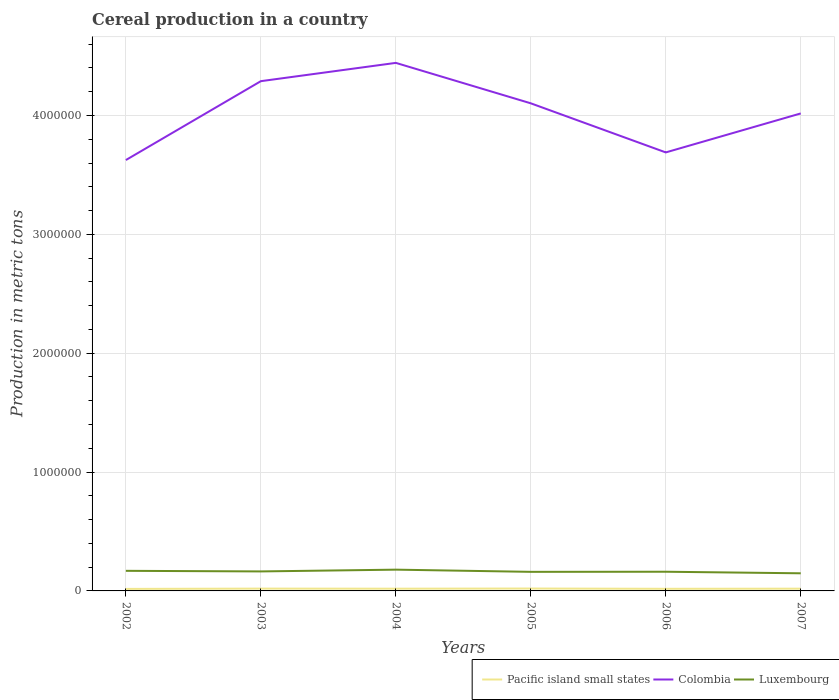Does the line corresponding to Pacific island small states intersect with the line corresponding to Luxembourg?
Offer a very short reply. No. Across all years, what is the maximum total cereal production in Colombia?
Ensure brevity in your answer.  3.63e+06. In which year was the total cereal production in Colombia maximum?
Provide a short and direct response. 2002. What is the total total cereal production in Pacific island small states in the graph?
Provide a short and direct response. -969. What is the difference between the highest and the second highest total cereal production in Pacific island small states?
Keep it short and to the point. 3224. What is the difference between the highest and the lowest total cereal production in Pacific island small states?
Offer a very short reply. 4. How many years are there in the graph?
Offer a very short reply. 6. Does the graph contain any zero values?
Your answer should be compact. No. How many legend labels are there?
Keep it short and to the point. 3. What is the title of the graph?
Your answer should be very brief. Cereal production in a country. Does "Upper middle income" appear as one of the legend labels in the graph?
Make the answer very short. No. What is the label or title of the X-axis?
Make the answer very short. Years. What is the label or title of the Y-axis?
Keep it short and to the point. Production in metric tons. What is the Production in metric tons of Pacific island small states in 2002?
Offer a very short reply. 1.69e+04. What is the Production in metric tons of Colombia in 2002?
Provide a short and direct response. 3.63e+06. What is the Production in metric tons in Luxembourg in 2002?
Provide a succinct answer. 1.69e+05. What is the Production in metric tons in Pacific island small states in 2003?
Provide a succinct answer. 1.95e+04. What is the Production in metric tons in Colombia in 2003?
Your answer should be compact. 4.29e+06. What is the Production in metric tons in Luxembourg in 2003?
Offer a very short reply. 1.64e+05. What is the Production in metric tons of Pacific island small states in 2004?
Offer a terse response. 1.88e+04. What is the Production in metric tons in Colombia in 2004?
Your answer should be very brief. 4.44e+06. What is the Production in metric tons of Luxembourg in 2004?
Make the answer very short. 1.79e+05. What is the Production in metric tons in Pacific island small states in 2005?
Keep it short and to the point. 2.01e+04. What is the Production in metric tons of Colombia in 2005?
Make the answer very short. 4.10e+06. What is the Production in metric tons of Luxembourg in 2005?
Offer a terse response. 1.61e+05. What is the Production in metric tons in Pacific island small states in 2006?
Make the answer very short. 1.79e+04. What is the Production in metric tons of Colombia in 2006?
Your answer should be compact. 3.69e+06. What is the Production in metric tons of Luxembourg in 2006?
Offer a terse response. 1.61e+05. What is the Production in metric tons in Pacific island small states in 2007?
Make the answer very short. 1.90e+04. What is the Production in metric tons in Colombia in 2007?
Provide a short and direct response. 4.02e+06. What is the Production in metric tons of Luxembourg in 2007?
Provide a short and direct response. 1.48e+05. Across all years, what is the maximum Production in metric tons of Pacific island small states?
Offer a terse response. 2.01e+04. Across all years, what is the maximum Production in metric tons of Colombia?
Keep it short and to the point. 4.44e+06. Across all years, what is the maximum Production in metric tons in Luxembourg?
Make the answer very short. 1.79e+05. Across all years, what is the minimum Production in metric tons in Pacific island small states?
Provide a succinct answer. 1.69e+04. Across all years, what is the minimum Production in metric tons in Colombia?
Provide a succinct answer. 3.63e+06. Across all years, what is the minimum Production in metric tons of Luxembourg?
Your answer should be very brief. 1.48e+05. What is the total Production in metric tons in Pacific island small states in the graph?
Your answer should be very brief. 1.12e+05. What is the total Production in metric tons of Colombia in the graph?
Make the answer very short. 2.42e+07. What is the total Production in metric tons in Luxembourg in the graph?
Provide a succinct answer. 9.83e+05. What is the difference between the Production in metric tons in Pacific island small states in 2002 and that in 2003?
Offer a very short reply. -2565. What is the difference between the Production in metric tons in Colombia in 2002 and that in 2003?
Your answer should be compact. -6.64e+05. What is the difference between the Production in metric tons of Luxembourg in 2002 and that in 2003?
Provide a short and direct response. 4928. What is the difference between the Production in metric tons of Pacific island small states in 2002 and that in 2004?
Make the answer very short. -1947. What is the difference between the Production in metric tons of Colombia in 2002 and that in 2004?
Offer a very short reply. -8.18e+05. What is the difference between the Production in metric tons in Luxembourg in 2002 and that in 2004?
Offer a very short reply. -9946. What is the difference between the Production in metric tons of Pacific island small states in 2002 and that in 2005?
Give a very brief answer. -3224. What is the difference between the Production in metric tons in Colombia in 2002 and that in 2005?
Make the answer very short. -4.77e+05. What is the difference between the Production in metric tons of Luxembourg in 2002 and that in 2005?
Keep it short and to the point. 8469. What is the difference between the Production in metric tons in Pacific island small states in 2002 and that in 2006?
Ensure brevity in your answer.  -969. What is the difference between the Production in metric tons of Colombia in 2002 and that in 2006?
Offer a terse response. -6.43e+04. What is the difference between the Production in metric tons in Luxembourg in 2002 and that in 2006?
Your answer should be very brief. 7577. What is the difference between the Production in metric tons in Pacific island small states in 2002 and that in 2007?
Keep it short and to the point. -2077. What is the difference between the Production in metric tons of Colombia in 2002 and that in 2007?
Provide a short and direct response. -3.92e+05. What is the difference between the Production in metric tons of Luxembourg in 2002 and that in 2007?
Ensure brevity in your answer.  2.07e+04. What is the difference between the Production in metric tons in Pacific island small states in 2003 and that in 2004?
Your answer should be compact. 618. What is the difference between the Production in metric tons of Colombia in 2003 and that in 2004?
Ensure brevity in your answer.  -1.54e+05. What is the difference between the Production in metric tons in Luxembourg in 2003 and that in 2004?
Offer a very short reply. -1.49e+04. What is the difference between the Production in metric tons in Pacific island small states in 2003 and that in 2005?
Provide a short and direct response. -659. What is the difference between the Production in metric tons in Colombia in 2003 and that in 2005?
Provide a short and direct response. 1.86e+05. What is the difference between the Production in metric tons in Luxembourg in 2003 and that in 2005?
Your answer should be compact. 3541. What is the difference between the Production in metric tons in Pacific island small states in 2003 and that in 2006?
Your answer should be compact. 1596. What is the difference between the Production in metric tons of Colombia in 2003 and that in 2006?
Your answer should be very brief. 5.99e+05. What is the difference between the Production in metric tons in Luxembourg in 2003 and that in 2006?
Ensure brevity in your answer.  2649. What is the difference between the Production in metric tons in Pacific island small states in 2003 and that in 2007?
Your answer should be compact. 488. What is the difference between the Production in metric tons in Colombia in 2003 and that in 2007?
Your response must be concise. 2.71e+05. What is the difference between the Production in metric tons of Luxembourg in 2003 and that in 2007?
Your answer should be very brief. 1.58e+04. What is the difference between the Production in metric tons of Pacific island small states in 2004 and that in 2005?
Your answer should be compact. -1277. What is the difference between the Production in metric tons in Colombia in 2004 and that in 2005?
Ensure brevity in your answer.  3.40e+05. What is the difference between the Production in metric tons of Luxembourg in 2004 and that in 2005?
Provide a short and direct response. 1.84e+04. What is the difference between the Production in metric tons of Pacific island small states in 2004 and that in 2006?
Offer a terse response. 978. What is the difference between the Production in metric tons in Colombia in 2004 and that in 2006?
Ensure brevity in your answer.  7.53e+05. What is the difference between the Production in metric tons in Luxembourg in 2004 and that in 2006?
Make the answer very short. 1.75e+04. What is the difference between the Production in metric tons in Pacific island small states in 2004 and that in 2007?
Ensure brevity in your answer.  -130. What is the difference between the Production in metric tons in Colombia in 2004 and that in 2007?
Provide a short and direct response. 4.25e+05. What is the difference between the Production in metric tons of Luxembourg in 2004 and that in 2007?
Ensure brevity in your answer.  3.06e+04. What is the difference between the Production in metric tons of Pacific island small states in 2005 and that in 2006?
Keep it short and to the point. 2255. What is the difference between the Production in metric tons of Colombia in 2005 and that in 2006?
Make the answer very short. 4.13e+05. What is the difference between the Production in metric tons of Luxembourg in 2005 and that in 2006?
Your answer should be compact. -892. What is the difference between the Production in metric tons of Pacific island small states in 2005 and that in 2007?
Provide a succinct answer. 1147. What is the difference between the Production in metric tons in Colombia in 2005 and that in 2007?
Offer a terse response. 8.50e+04. What is the difference between the Production in metric tons of Luxembourg in 2005 and that in 2007?
Keep it short and to the point. 1.22e+04. What is the difference between the Production in metric tons of Pacific island small states in 2006 and that in 2007?
Ensure brevity in your answer.  -1108. What is the difference between the Production in metric tons in Colombia in 2006 and that in 2007?
Your response must be concise. -3.28e+05. What is the difference between the Production in metric tons of Luxembourg in 2006 and that in 2007?
Keep it short and to the point. 1.31e+04. What is the difference between the Production in metric tons of Pacific island small states in 2002 and the Production in metric tons of Colombia in 2003?
Give a very brief answer. -4.27e+06. What is the difference between the Production in metric tons in Pacific island small states in 2002 and the Production in metric tons in Luxembourg in 2003?
Make the answer very short. -1.47e+05. What is the difference between the Production in metric tons of Colombia in 2002 and the Production in metric tons of Luxembourg in 2003?
Your answer should be compact. 3.46e+06. What is the difference between the Production in metric tons in Pacific island small states in 2002 and the Production in metric tons in Colombia in 2004?
Give a very brief answer. -4.43e+06. What is the difference between the Production in metric tons in Pacific island small states in 2002 and the Production in metric tons in Luxembourg in 2004?
Offer a very short reply. -1.62e+05. What is the difference between the Production in metric tons of Colombia in 2002 and the Production in metric tons of Luxembourg in 2004?
Provide a short and direct response. 3.45e+06. What is the difference between the Production in metric tons of Pacific island small states in 2002 and the Production in metric tons of Colombia in 2005?
Your response must be concise. -4.09e+06. What is the difference between the Production in metric tons of Pacific island small states in 2002 and the Production in metric tons of Luxembourg in 2005?
Your answer should be very brief. -1.44e+05. What is the difference between the Production in metric tons in Colombia in 2002 and the Production in metric tons in Luxembourg in 2005?
Provide a succinct answer. 3.46e+06. What is the difference between the Production in metric tons of Pacific island small states in 2002 and the Production in metric tons of Colombia in 2006?
Give a very brief answer. -3.67e+06. What is the difference between the Production in metric tons of Pacific island small states in 2002 and the Production in metric tons of Luxembourg in 2006?
Your answer should be compact. -1.45e+05. What is the difference between the Production in metric tons of Colombia in 2002 and the Production in metric tons of Luxembourg in 2006?
Ensure brevity in your answer.  3.46e+06. What is the difference between the Production in metric tons in Pacific island small states in 2002 and the Production in metric tons in Colombia in 2007?
Give a very brief answer. -4.00e+06. What is the difference between the Production in metric tons of Pacific island small states in 2002 and the Production in metric tons of Luxembourg in 2007?
Provide a succinct answer. -1.31e+05. What is the difference between the Production in metric tons of Colombia in 2002 and the Production in metric tons of Luxembourg in 2007?
Your answer should be very brief. 3.48e+06. What is the difference between the Production in metric tons of Pacific island small states in 2003 and the Production in metric tons of Colombia in 2004?
Your response must be concise. -4.42e+06. What is the difference between the Production in metric tons of Pacific island small states in 2003 and the Production in metric tons of Luxembourg in 2004?
Make the answer very short. -1.60e+05. What is the difference between the Production in metric tons in Colombia in 2003 and the Production in metric tons in Luxembourg in 2004?
Your response must be concise. 4.11e+06. What is the difference between the Production in metric tons in Pacific island small states in 2003 and the Production in metric tons in Colombia in 2005?
Make the answer very short. -4.08e+06. What is the difference between the Production in metric tons in Pacific island small states in 2003 and the Production in metric tons in Luxembourg in 2005?
Your answer should be very brief. -1.41e+05. What is the difference between the Production in metric tons in Colombia in 2003 and the Production in metric tons in Luxembourg in 2005?
Provide a succinct answer. 4.13e+06. What is the difference between the Production in metric tons in Pacific island small states in 2003 and the Production in metric tons in Colombia in 2006?
Make the answer very short. -3.67e+06. What is the difference between the Production in metric tons in Pacific island small states in 2003 and the Production in metric tons in Luxembourg in 2006?
Offer a terse response. -1.42e+05. What is the difference between the Production in metric tons of Colombia in 2003 and the Production in metric tons of Luxembourg in 2006?
Offer a terse response. 4.13e+06. What is the difference between the Production in metric tons in Pacific island small states in 2003 and the Production in metric tons in Colombia in 2007?
Make the answer very short. -4.00e+06. What is the difference between the Production in metric tons of Pacific island small states in 2003 and the Production in metric tons of Luxembourg in 2007?
Offer a terse response. -1.29e+05. What is the difference between the Production in metric tons in Colombia in 2003 and the Production in metric tons in Luxembourg in 2007?
Make the answer very short. 4.14e+06. What is the difference between the Production in metric tons of Pacific island small states in 2004 and the Production in metric tons of Colombia in 2005?
Your answer should be very brief. -4.08e+06. What is the difference between the Production in metric tons in Pacific island small states in 2004 and the Production in metric tons in Luxembourg in 2005?
Make the answer very short. -1.42e+05. What is the difference between the Production in metric tons of Colombia in 2004 and the Production in metric tons of Luxembourg in 2005?
Offer a terse response. 4.28e+06. What is the difference between the Production in metric tons in Pacific island small states in 2004 and the Production in metric tons in Colombia in 2006?
Ensure brevity in your answer.  -3.67e+06. What is the difference between the Production in metric tons of Pacific island small states in 2004 and the Production in metric tons of Luxembourg in 2006?
Provide a succinct answer. -1.43e+05. What is the difference between the Production in metric tons in Colombia in 2004 and the Production in metric tons in Luxembourg in 2006?
Ensure brevity in your answer.  4.28e+06. What is the difference between the Production in metric tons in Pacific island small states in 2004 and the Production in metric tons in Colombia in 2007?
Give a very brief answer. -4.00e+06. What is the difference between the Production in metric tons in Pacific island small states in 2004 and the Production in metric tons in Luxembourg in 2007?
Give a very brief answer. -1.30e+05. What is the difference between the Production in metric tons of Colombia in 2004 and the Production in metric tons of Luxembourg in 2007?
Give a very brief answer. 4.29e+06. What is the difference between the Production in metric tons of Pacific island small states in 2005 and the Production in metric tons of Colombia in 2006?
Your response must be concise. -3.67e+06. What is the difference between the Production in metric tons of Pacific island small states in 2005 and the Production in metric tons of Luxembourg in 2006?
Your answer should be very brief. -1.41e+05. What is the difference between the Production in metric tons in Colombia in 2005 and the Production in metric tons in Luxembourg in 2006?
Offer a very short reply. 3.94e+06. What is the difference between the Production in metric tons of Pacific island small states in 2005 and the Production in metric tons of Colombia in 2007?
Your answer should be compact. -4.00e+06. What is the difference between the Production in metric tons of Pacific island small states in 2005 and the Production in metric tons of Luxembourg in 2007?
Your answer should be very brief. -1.28e+05. What is the difference between the Production in metric tons in Colombia in 2005 and the Production in metric tons in Luxembourg in 2007?
Your answer should be compact. 3.95e+06. What is the difference between the Production in metric tons of Pacific island small states in 2006 and the Production in metric tons of Colombia in 2007?
Ensure brevity in your answer.  -4.00e+06. What is the difference between the Production in metric tons in Pacific island small states in 2006 and the Production in metric tons in Luxembourg in 2007?
Your answer should be very brief. -1.30e+05. What is the difference between the Production in metric tons in Colombia in 2006 and the Production in metric tons in Luxembourg in 2007?
Offer a very short reply. 3.54e+06. What is the average Production in metric tons of Pacific island small states per year?
Your response must be concise. 1.87e+04. What is the average Production in metric tons in Colombia per year?
Provide a succinct answer. 4.03e+06. What is the average Production in metric tons in Luxembourg per year?
Make the answer very short. 1.64e+05. In the year 2002, what is the difference between the Production in metric tons in Pacific island small states and Production in metric tons in Colombia?
Offer a very short reply. -3.61e+06. In the year 2002, what is the difference between the Production in metric tons of Pacific island small states and Production in metric tons of Luxembourg?
Offer a terse response. -1.52e+05. In the year 2002, what is the difference between the Production in metric tons in Colombia and Production in metric tons in Luxembourg?
Your response must be concise. 3.46e+06. In the year 2003, what is the difference between the Production in metric tons in Pacific island small states and Production in metric tons in Colombia?
Your answer should be compact. -4.27e+06. In the year 2003, what is the difference between the Production in metric tons in Pacific island small states and Production in metric tons in Luxembourg?
Provide a short and direct response. -1.45e+05. In the year 2003, what is the difference between the Production in metric tons in Colombia and Production in metric tons in Luxembourg?
Make the answer very short. 4.12e+06. In the year 2004, what is the difference between the Production in metric tons in Pacific island small states and Production in metric tons in Colombia?
Your answer should be compact. -4.42e+06. In the year 2004, what is the difference between the Production in metric tons in Pacific island small states and Production in metric tons in Luxembourg?
Keep it short and to the point. -1.60e+05. In the year 2004, what is the difference between the Production in metric tons of Colombia and Production in metric tons of Luxembourg?
Offer a very short reply. 4.26e+06. In the year 2005, what is the difference between the Production in metric tons of Pacific island small states and Production in metric tons of Colombia?
Offer a very short reply. -4.08e+06. In the year 2005, what is the difference between the Production in metric tons in Pacific island small states and Production in metric tons in Luxembourg?
Your answer should be very brief. -1.40e+05. In the year 2005, what is the difference between the Production in metric tons in Colombia and Production in metric tons in Luxembourg?
Provide a succinct answer. 3.94e+06. In the year 2006, what is the difference between the Production in metric tons of Pacific island small states and Production in metric tons of Colombia?
Your answer should be compact. -3.67e+06. In the year 2006, what is the difference between the Production in metric tons of Pacific island small states and Production in metric tons of Luxembourg?
Offer a very short reply. -1.44e+05. In the year 2006, what is the difference between the Production in metric tons of Colombia and Production in metric tons of Luxembourg?
Your response must be concise. 3.53e+06. In the year 2007, what is the difference between the Production in metric tons of Pacific island small states and Production in metric tons of Colombia?
Provide a short and direct response. -4.00e+06. In the year 2007, what is the difference between the Production in metric tons in Pacific island small states and Production in metric tons in Luxembourg?
Provide a short and direct response. -1.29e+05. In the year 2007, what is the difference between the Production in metric tons of Colombia and Production in metric tons of Luxembourg?
Offer a terse response. 3.87e+06. What is the ratio of the Production in metric tons of Pacific island small states in 2002 to that in 2003?
Offer a very short reply. 0.87. What is the ratio of the Production in metric tons of Colombia in 2002 to that in 2003?
Keep it short and to the point. 0.85. What is the ratio of the Production in metric tons in Luxembourg in 2002 to that in 2003?
Make the answer very short. 1.03. What is the ratio of the Production in metric tons of Pacific island small states in 2002 to that in 2004?
Give a very brief answer. 0.9. What is the ratio of the Production in metric tons in Colombia in 2002 to that in 2004?
Ensure brevity in your answer.  0.82. What is the ratio of the Production in metric tons in Luxembourg in 2002 to that in 2004?
Your response must be concise. 0.94. What is the ratio of the Production in metric tons in Pacific island small states in 2002 to that in 2005?
Ensure brevity in your answer.  0.84. What is the ratio of the Production in metric tons of Colombia in 2002 to that in 2005?
Your answer should be compact. 0.88. What is the ratio of the Production in metric tons of Luxembourg in 2002 to that in 2005?
Your answer should be very brief. 1.05. What is the ratio of the Production in metric tons in Pacific island small states in 2002 to that in 2006?
Provide a short and direct response. 0.95. What is the ratio of the Production in metric tons of Colombia in 2002 to that in 2006?
Your response must be concise. 0.98. What is the ratio of the Production in metric tons in Luxembourg in 2002 to that in 2006?
Provide a short and direct response. 1.05. What is the ratio of the Production in metric tons of Pacific island small states in 2002 to that in 2007?
Keep it short and to the point. 0.89. What is the ratio of the Production in metric tons in Colombia in 2002 to that in 2007?
Make the answer very short. 0.9. What is the ratio of the Production in metric tons in Luxembourg in 2002 to that in 2007?
Give a very brief answer. 1.14. What is the ratio of the Production in metric tons in Pacific island small states in 2003 to that in 2004?
Make the answer very short. 1.03. What is the ratio of the Production in metric tons in Colombia in 2003 to that in 2004?
Ensure brevity in your answer.  0.97. What is the ratio of the Production in metric tons of Luxembourg in 2003 to that in 2004?
Give a very brief answer. 0.92. What is the ratio of the Production in metric tons of Pacific island small states in 2003 to that in 2005?
Your answer should be very brief. 0.97. What is the ratio of the Production in metric tons of Colombia in 2003 to that in 2005?
Keep it short and to the point. 1.05. What is the ratio of the Production in metric tons of Luxembourg in 2003 to that in 2005?
Give a very brief answer. 1.02. What is the ratio of the Production in metric tons of Pacific island small states in 2003 to that in 2006?
Your answer should be very brief. 1.09. What is the ratio of the Production in metric tons in Colombia in 2003 to that in 2006?
Your answer should be compact. 1.16. What is the ratio of the Production in metric tons in Luxembourg in 2003 to that in 2006?
Provide a short and direct response. 1.02. What is the ratio of the Production in metric tons of Pacific island small states in 2003 to that in 2007?
Make the answer very short. 1.03. What is the ratio of the Production in metric tons in Colombia in 2003 to that in 2007?
Give a very brief answer. 1.07. What is the ratio of the Production in metric tons of Luxembourg in 2003 to that in 2007?
Provide a succinct answer. 1.11. What is the ratio of the Production in metric tons of Pacific island small states in 2004 to that in 2005?
Offer a terse response. 0.94. What is the ratio of the Production in metric tons in Colombia in 2004 to that in 2005?
Provide a short and direct response. 1.08. What is the ratio of the Production in metric tons of Luxembourg in 2004 to that in 2005?
Provide a succinct answer. 1.11. What is the ratio of the Production in metric tons of Pacific island small states in 2004 to that in 2006?
Your answer should be compact. 1.05. What is the ratio of the Production in metric tons of Colombia in 2004 to that in 2006?
Provide a succinct answer. 1.2. What is the ratio of the Production in metric tons in Luxembourg in 2004 to that in 2006?
Make the answer very short. 1.11. What is the ratio of the Production in metric tons in Colombia in 2004 to that in 2007?
Provide a succinct answer. 1.11. What is the ratio of the Production in metric tons of Luxembourg in 2004 to that in 2007?
Ensure brevity in your answer.  1.21. What is the ratio of the Production in metric tons of Pacific island small states in 2005 to that in 2006?
Offer a very short reply. 1.13. What is the ratio of the Production in metric tons in Colombia in 2005 to that in 2006?
Make the answer very short. 1.11. What is the ratio of the Production in metric tons in Pacific island small states in 2005 to that in 2007?
Give a very brief answer. 1.06. What is the ratio of the Production in metric tons in Colombia in 2005 to that in 2007?
Your response must be concise. 1.02. What is the ratio of the Production in metric tons of Luxembourg in 2005 to that in 2007?
Your response must be concise. 1.08. What is the ratio of the Production in metric tons in Pacific island small states in 2006 to that in 2007?
Keep it short and to the point. 0.94. What is the ratio of the Production in metric tons in Colombia in 2006 to that in 2007?
Offer a terse response. 0.92. What is the ratio of the Production in metric tons in Luxembourg in 2006 to that in 2007?
Make the answer very short. 1.09. What is the difference between the highest and the second highest Production in metric tons of Pacific island small states?
Make the answer very short. 659. What is the difference between the highest and the second highest Production in metric tons of Colombia?
Your answer should be compact. 1.54e+05. What is the difference between the highest and the second highest Production in metric tons of Luxembourg?
Ensure brevity in your answer.  9946. What is the difference between the highest and the lowest Production in metric tons in Pacific island small states?
Keep it short and to the point. 3224. What is the difference between the highest and the lowest Production in metric tons of Colombia?
Keep it short and to the point. 8.18e+05. What is the difference between the highest and the lowest Production in metric tons in Luxembourg?
Your response must be concise. 3.06e+04. 